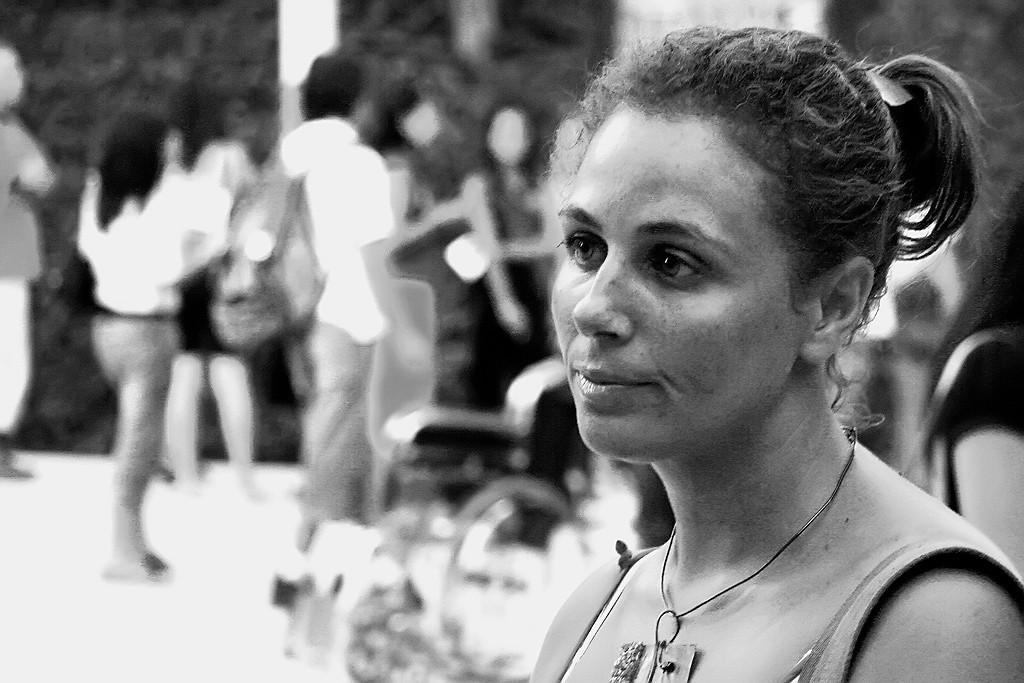What is the main subject of the image? There is a person in the image. Can you describe the background of the image? The background of the image is blurred. What color scheme is used in the image? The image is in black and white. What type of vegetable is being stored in the crate in the image? There is no crate or vegetable present in the image. Can you describe the bedroom setting in the image? There is no bedroom setting present in the image. 